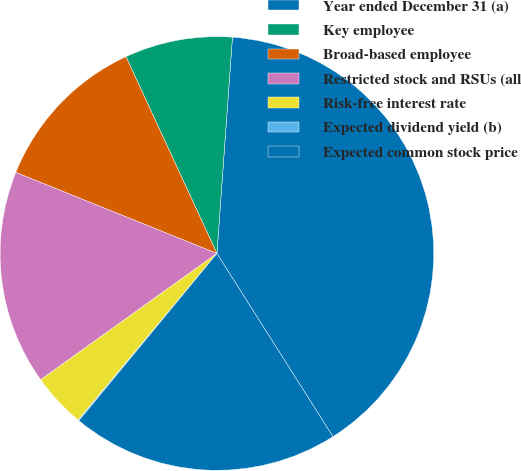<chart> <loc_0><loc_0><loc_500><loc_500><pie_chart><fcel>Year ended December 31 (a)<fcel>Key employee<fcel>Broad-based employee<fcel>Restricted stock and RSUs (all<fcel>Risk-free interest rate<fcel>Expected dividend yield (b)<fcel>Expected common stock price<nl><fcel>39.87%<fcel>8.03%<fcel>12.01%<fcel>15.99%<fcel>4.05%<fcel>0.07%<fcel>19.97%<nl></chart> 